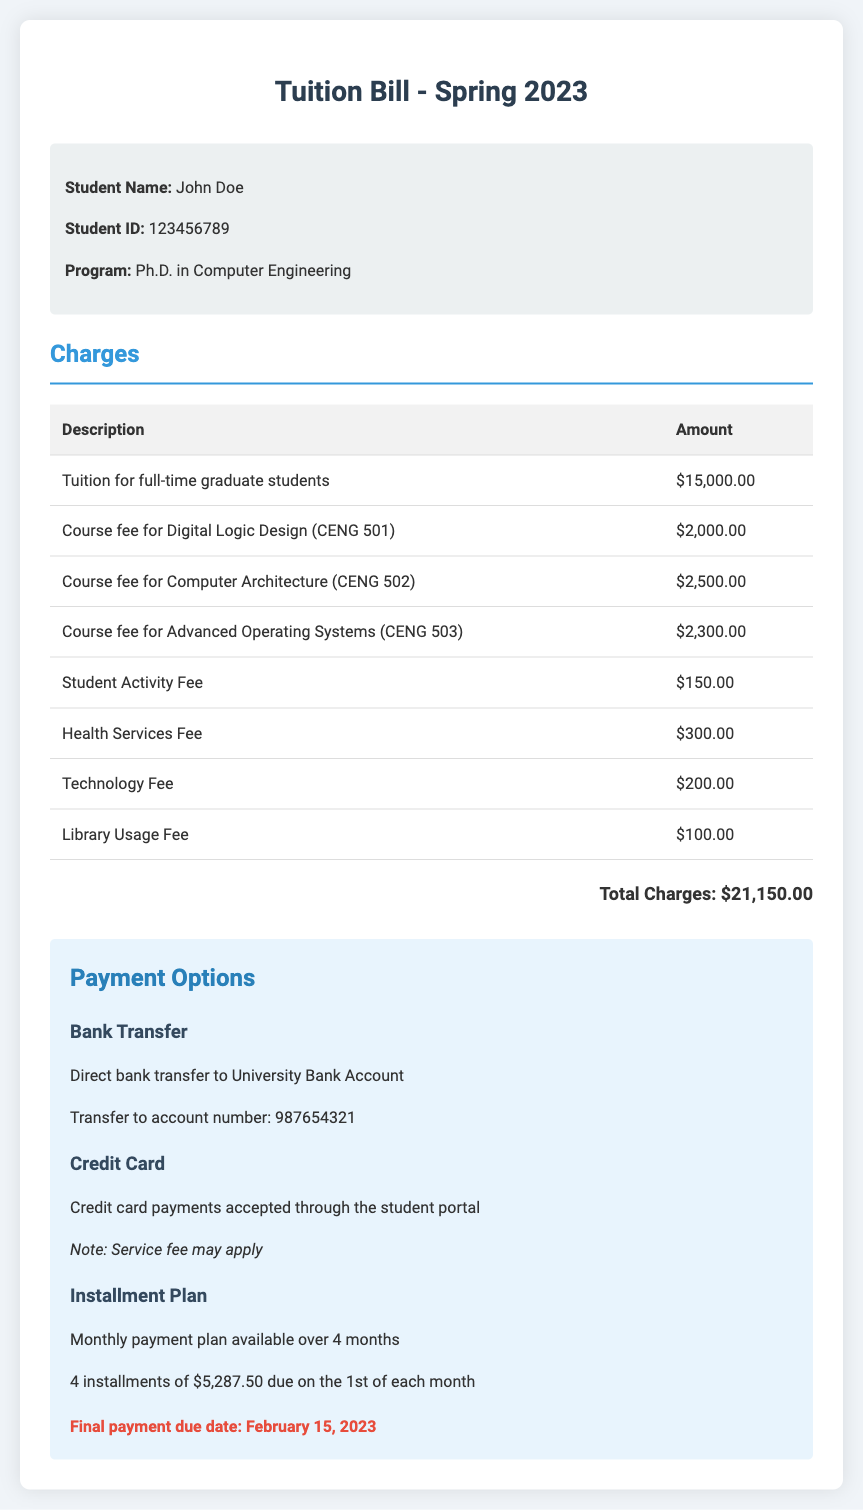What is the total amount of the tuition bill? The total amount of the tuition bill is indicated at the end of the charges section, which is $21,150.00.
Answer: $21,150.00 What is the due date for the final payment? The due date for the final payment is stated in the payment options section, which is February 15, 2023.
Answer: February 15, 2023 How much is the Student Activity Fee? The Student Activity Fee amount is listed in the charges section, which states $150.00.
Answer: $150.00 What is the course fee for Computer Architecture (CENG 502)? The course fee for Computer Architecture (CENG 502) is specified in the charges section as $2,500.00.
Answer: $2,500.00 How many installments are in the payment plan? The payment plan details state that there are 4 installments, providing reasoning through the installment plan description.
Answer: 4 What is the total amount for tuition for full-time graduate students? The tuition amount for full-time graduate students is given in the charges section, which is $15,000.00.
Answer: $15,000.00 What payment option requires a bank transfer? The document mentions a payment option for bank transfer, specifically describing it as such.
Answer: Bank Transfer What is the amount for the Technology Fee? The Technology Fee amount is provided in the charges section as $200.00.
Answer: $200.00 What is the description of the first course fee listed? The first course fee listed is for Digital Logic Design, as mentioned in the charges section.
Answer: Digital Logic Design (CENG 501) 